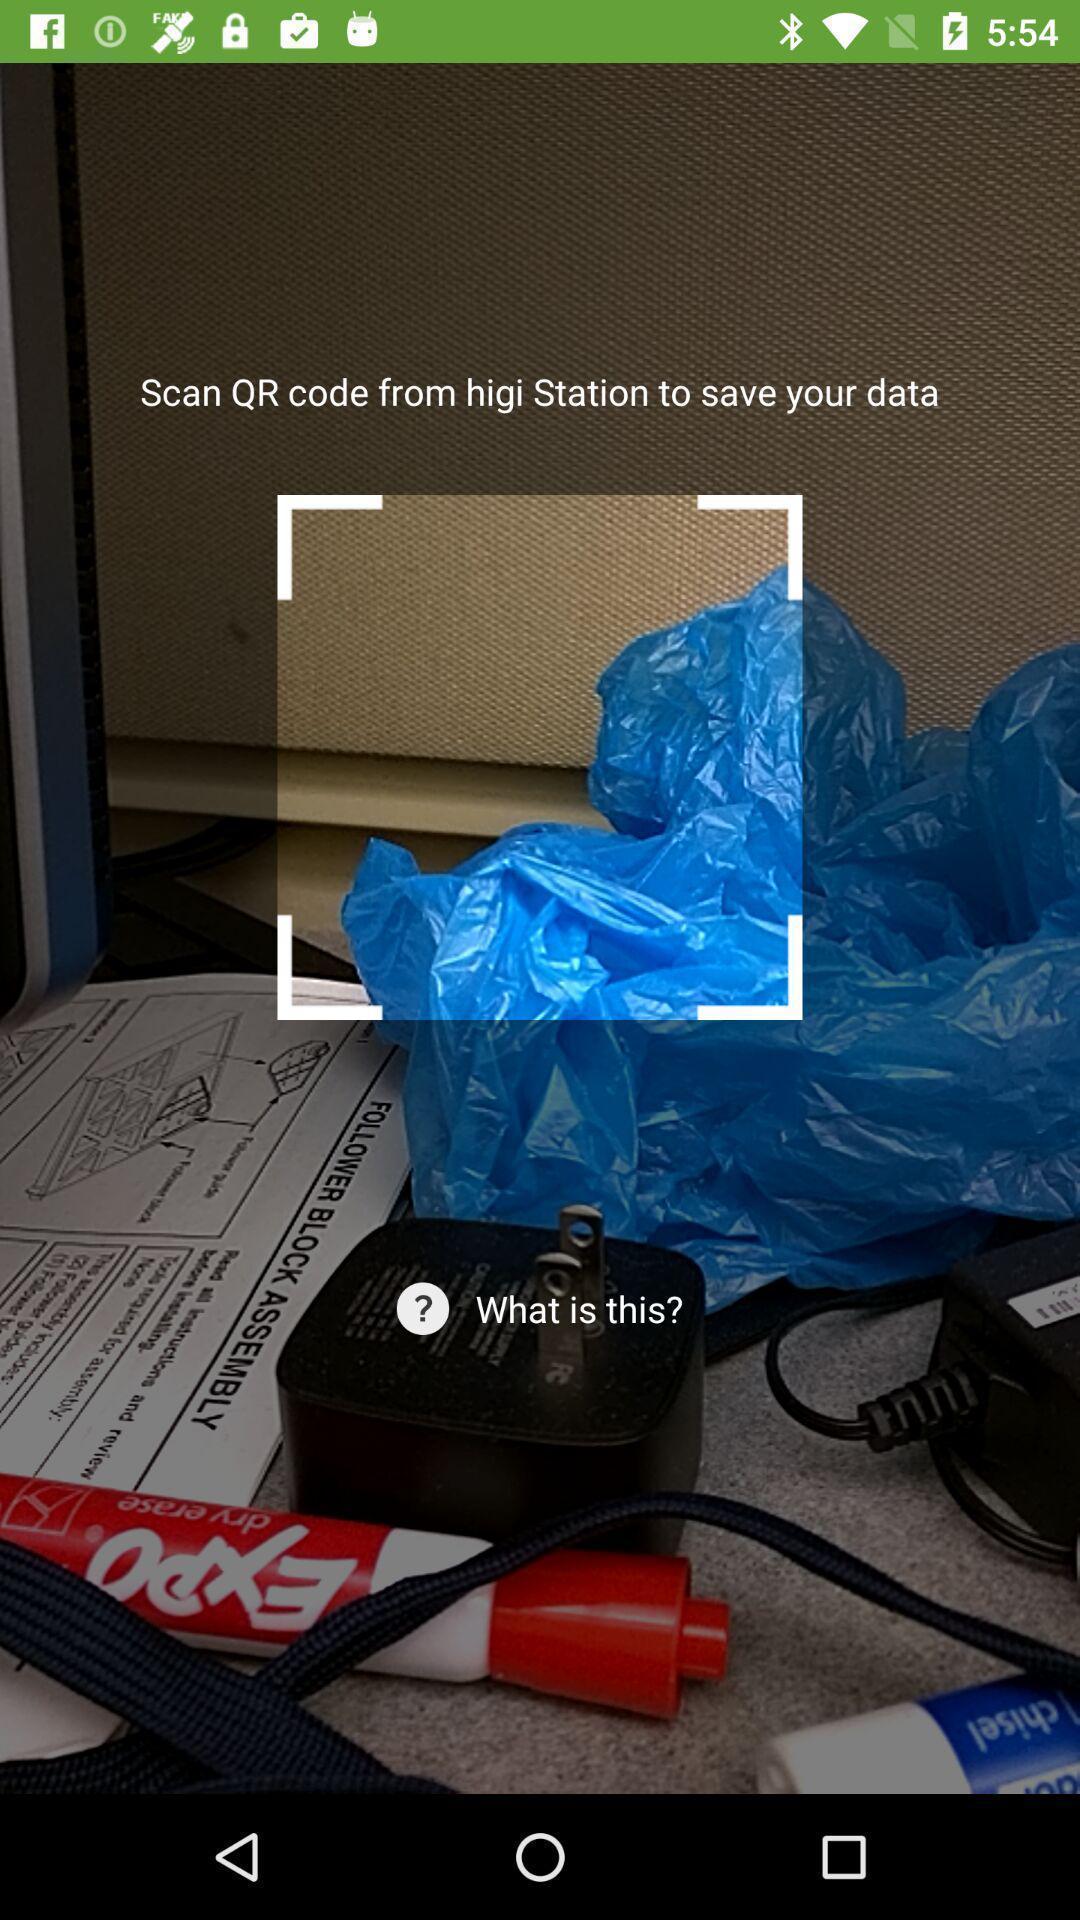Tell me what you see in this picture. Screen showing the option for qr code scanner. 